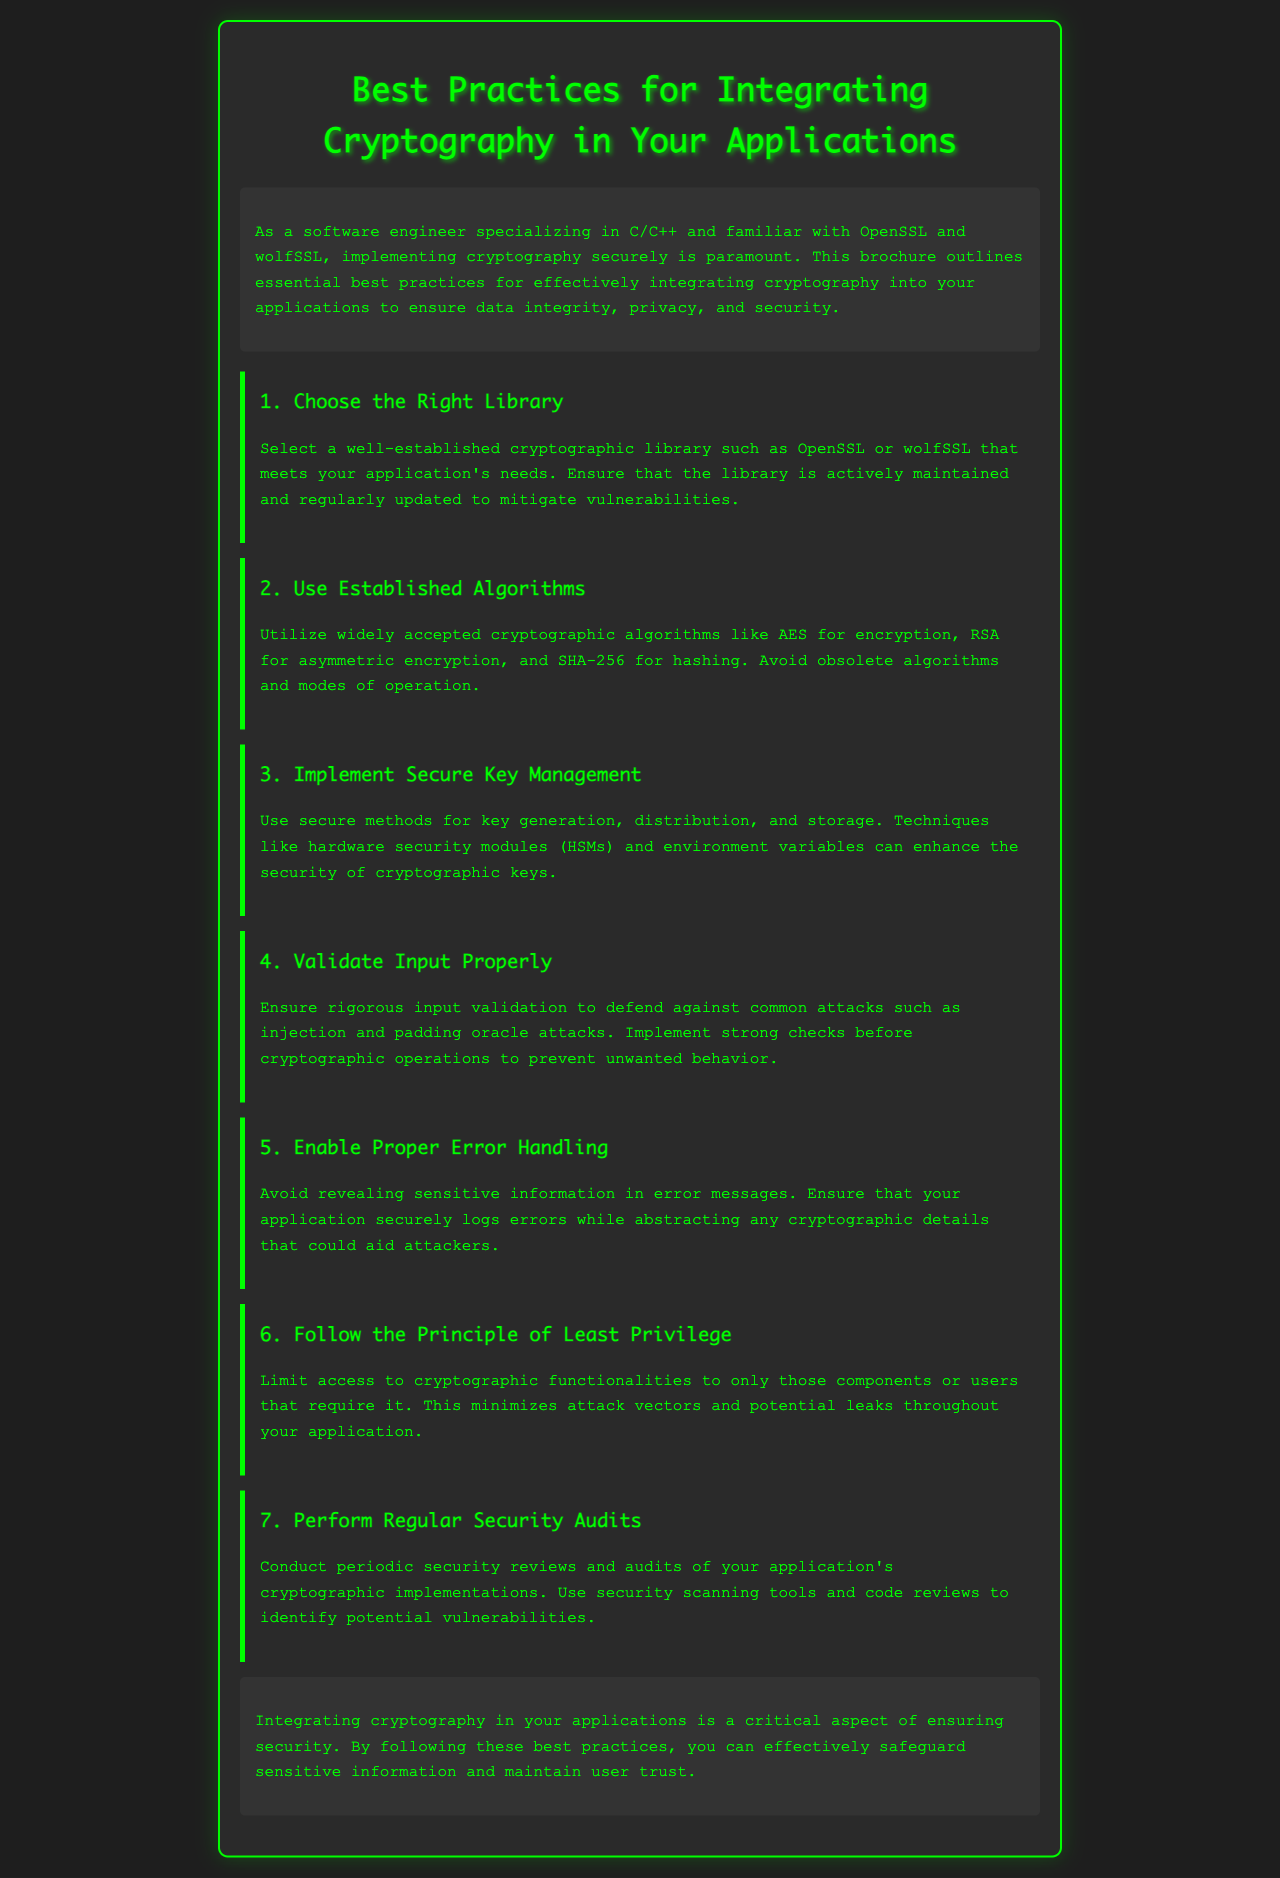What is the title of the brochure? The title is clearly stated at the top of the document.
Answer: Best Practices for Integrating Cryptography in Your Applications Which library is mentioned as a well-established cryptographic library? The document includes specific names of libraries in the first best practice section.
Answer: OpenSSL What is the secure method for key management mentioned? The document highlights methods for managing keys in the third best practice section.
Answer: Hardware security modules What algorithm is recommended for hashing? The second best practice section specifies algorithms for various operations.
Answer: SHA-256 How many best practices are outlined in the document? The number of best practices is listed at the beginning of each section of the document.
Answer: 7 What principle should be followed regarding access to cryptographic functionalities? The sixth best practice emphasizes a specific principle related to access.
Answer: Least Privilege What action should be taken periodically to ensure security? The seventh best practice section addresses this action directly.
Answer: Conduct periodic security audits 